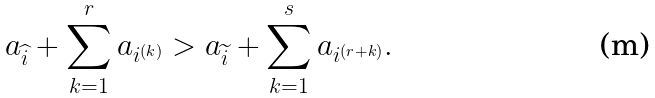Convert formula to latex. <formula><loc_0><loc_0><loc_500><loc_500>a _ { \widehat { i } } + \sum _ { k = 1 } ^ { r } a _ { i ^ { ( k ) } } > a _ { \widetilde { i } } + \sum _ { k = 1 } ^ { s } a _ { i ^ { ( r + k ) } } .</formula> 